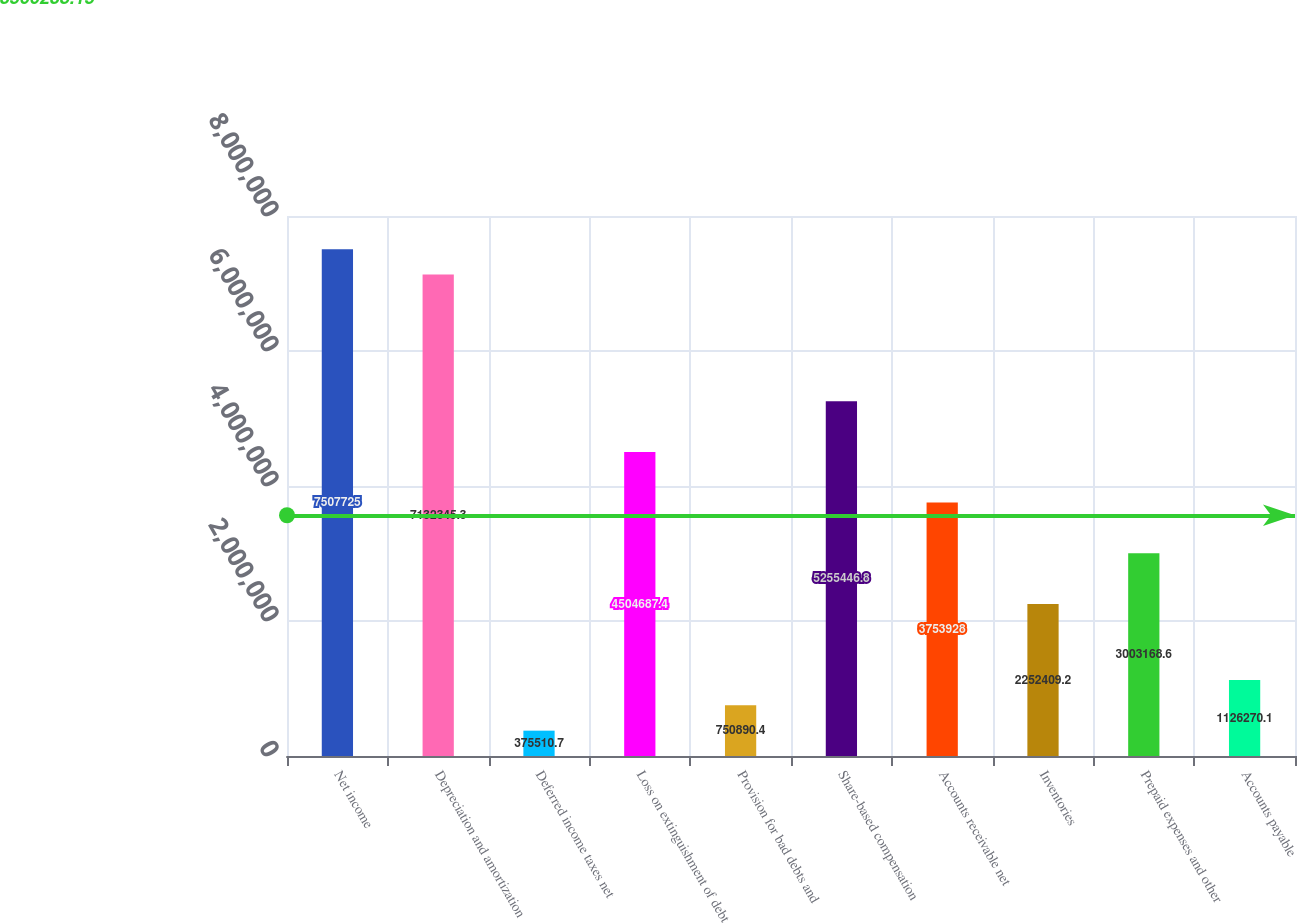Convert chart to OTSL. <chart><loc_0><loc_0><loc_500><loc_500><bar_chart><fcel>Net income<fcel>Depreciation and amortization<fcel>Deferred income taxes net<fcel>Loss on extinguishment of debt<fcel>Provision for bad debts and<fcel>Share-based compensation<fcel>Accounts receivable net<fcel>Inventories<fcel>Prepaid expenses and other<fcel>Accounts payable<nl><fcel>7.50772e+06<fcel>7.13235e+06<fcel>375511<fcel>4.50469e+06<fcel>750890<fcel>5.25545e+06<fcel>3.75393e+06<fcel>2.25241e+06<fcel>3.00317e+06<fcel>1.12627e+06<nl></chart> 